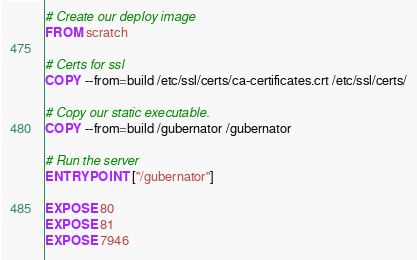Convert code to text. <code><loc_0><loc_0><loc_500><loc_500><_Dockerfile_>
# Create our deploy image
FROM scratch

# Certs for ssl
COPY --from=build /etc/ssl/certs/ca-certificates.crt /etc/ssl/certs/

# Copy our static executable.
COPY --from=build /gubernator /gubernator

# Run the server
ENTRYPOINT ["/gubernator"]

EXPOSE 80
EXPOSE 81
EXPOSE 7946
</code> 